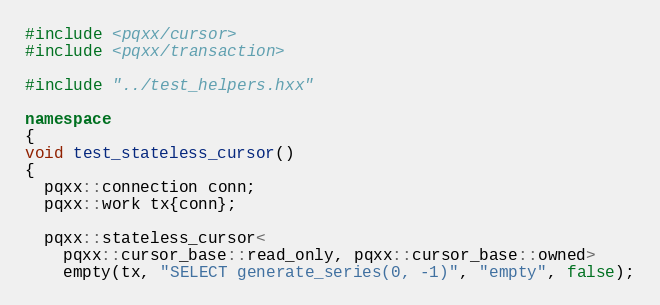<code> <loc_0><loc_0><loc_500><loc_500><_C++_>#include <pqxx/cursor>
#include <pqxx/transaction>

#include "../test_helpers.hxx"

namespace
{
void test_stateless_cursor()
{
  pqxx::connection conn;
  pqxx::work tx{conn};

  pqxx::stateless_cursor<
    pqxx::cursor_base::read_only, pqxx::cursor_base::owned>
    empty(tx, "SELECT generate_series(0, -1)", "empty", false);
</code> 